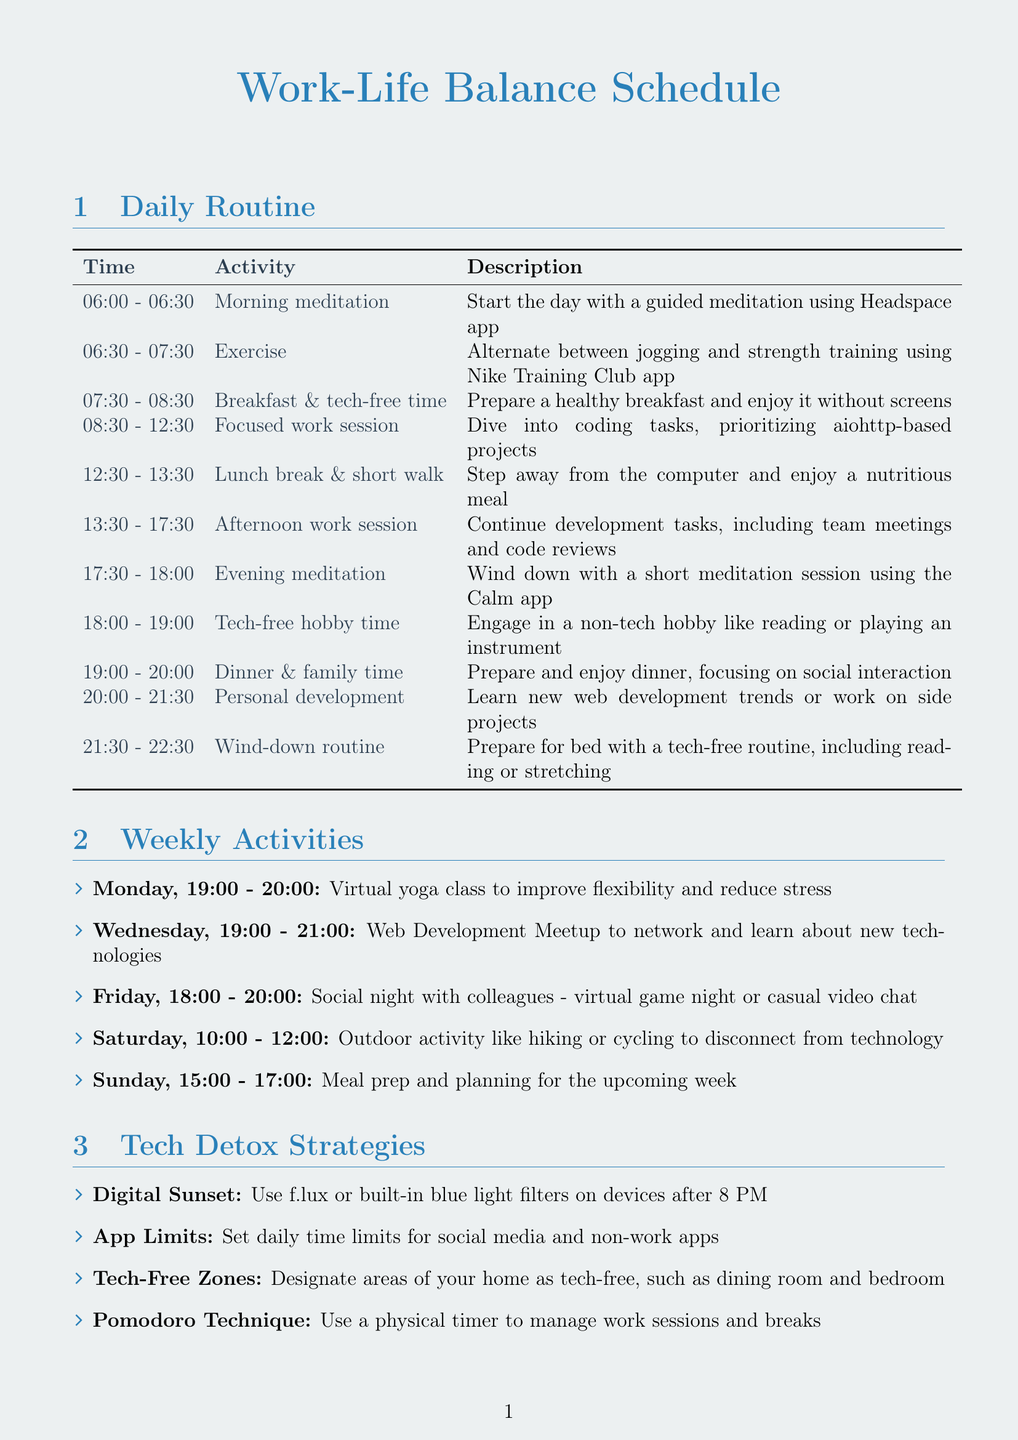what time is the morning meditation? The morning meditation is scheduled from 06:00 to 06:30.
Answer: 06:00 - 06:30 what activity follows the breakfast and tech-free time? After breakfast and tech-free time, the next activity is the focused work session.
Answer: Focused work session how long is the tech-free hobby time? The tech-free hobby time lasts for one hour, from 18:00 to 19:00.
Answer: 1 hour what day is the social night with colleagues scheduled? The social night with colleagues is on Friday.
Answer: Friday which app is suggested for evening meditation? The Calm app is suggested for evening meditation.
Answer: Calm app how does the schedule help in preventing burnout? The schedule includes activities like regular breaks, exercise, and mindfulness, which help reduce stress and keep motivation high.
Answer: Mindfulness breaks what is the suggested activity for Saturday? The suggested activity for Saturday is an outdoor activity.
Answer: Outdoor activity what is a tech detox strategy mentioned in the document? One of the tech detox strategies mentioned is to set daily app limits.
Answer: App Limits how many hours are allocated to personal development? Personal development is allocated one and a half hours.
Answer: 1.5 hours 